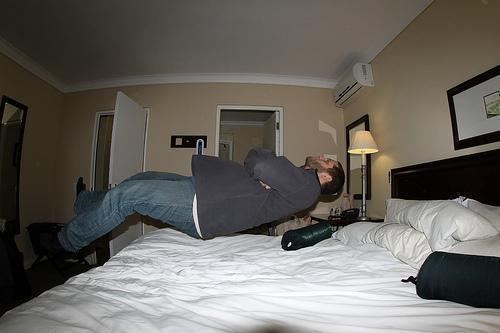How many people are there?
Give a very brief answer. 1. 